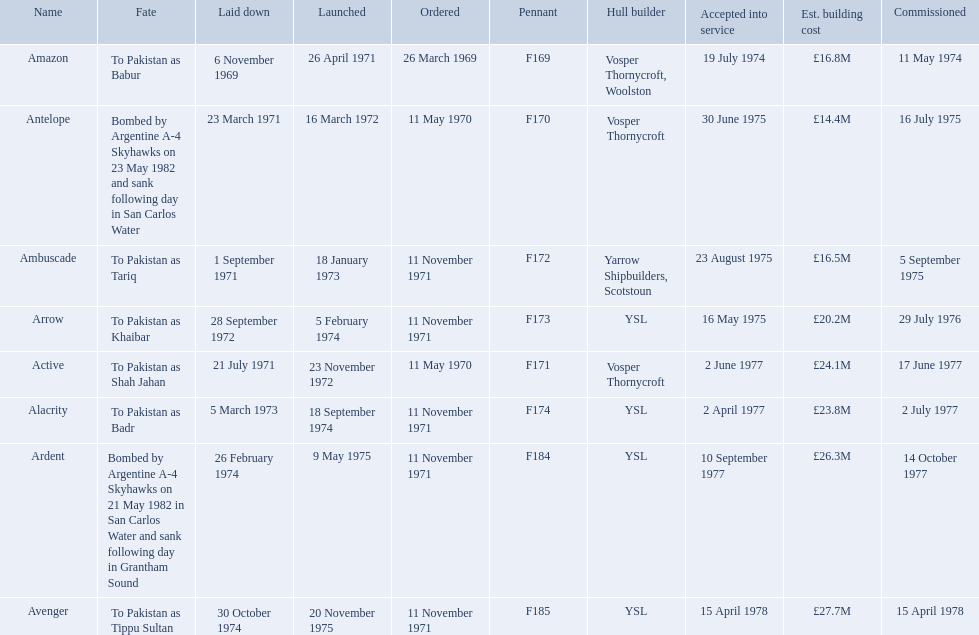Which type 21 frigate ships were to be built by ysl in the 1970s? Arrow, Alacrity, Ardent, Avenger. Of these ships, which one had the highest estimated building cost? Avenger. 